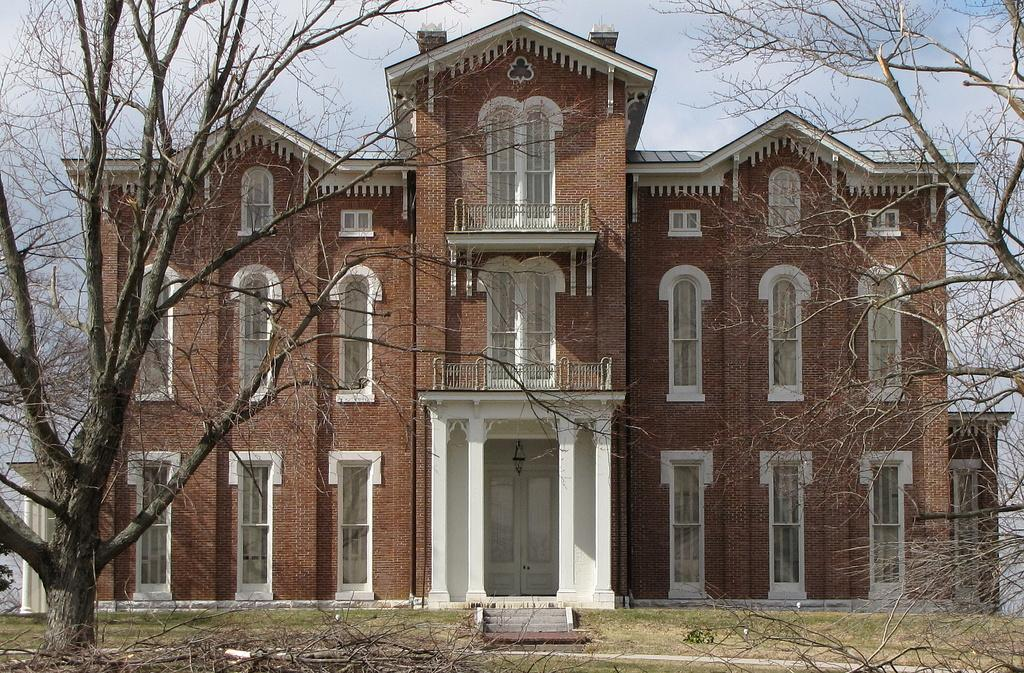What is the main structure visible in the image? There is a building in the image. What type of vegetation is present in front of the building? There are trees in front of the building. What objects can be seen on the surface in the image? There are wooden sticks on the surface in the image. What type of family can be seen interacting with the paint in the image? There is no family or paint present in the image; it only features a building, trees, and wooden sticks. 